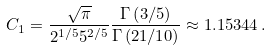Convert formula to latex. <formula><loc_0><loc_0><loc_500><loc_500>C _ { 1 } = \frac { \sqrt { \pi } } { 2 ^ { 1 / 5 } 5 ^ { 2 / 5 } } \frac { \Gamma \left ( 3 / 5 \right ) } { \Gamma \left ( 2 1 / 1 0 \right ) } \approx 1 . 1 5 3 4 4 \, .</formula> 